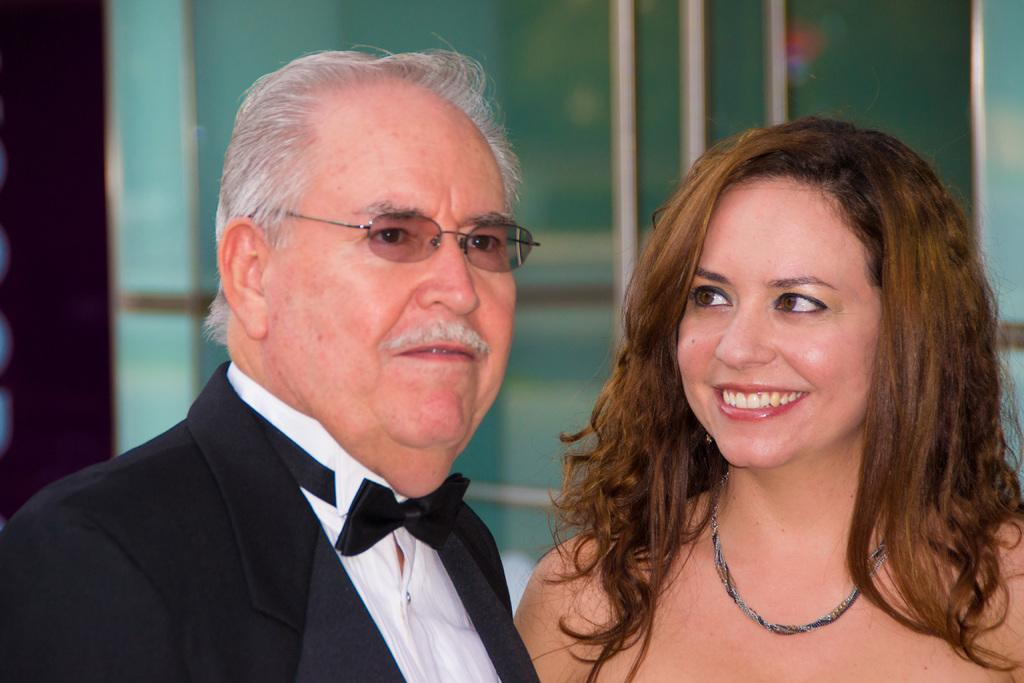What is the gender of the person on the left side of the image? There is a man on the left side of the image. What is the gender of the person on the right side of the image? There is a woman on the right side of the image. What can be seen in the background of the image? There are glass doors in the background of the image. Reasoning: Let' Let's think step by step in order to produce the conversation. We start by identifying the two main subjects in the image, which are the man on the left and the woman on the right. Then, we describe their genders based on the provided facts. Finally, we mention the background element, which is the glass doors. Each question is designed to elicit a specific detail about the image that is known from the provided facts. Absurd Question/Answer: Where is the cactus located in the image? There is no cactus present in the image. What attempt is being made by the man and woman in the image? The image does not depict any specific action or attempt being made by the man and woman. 